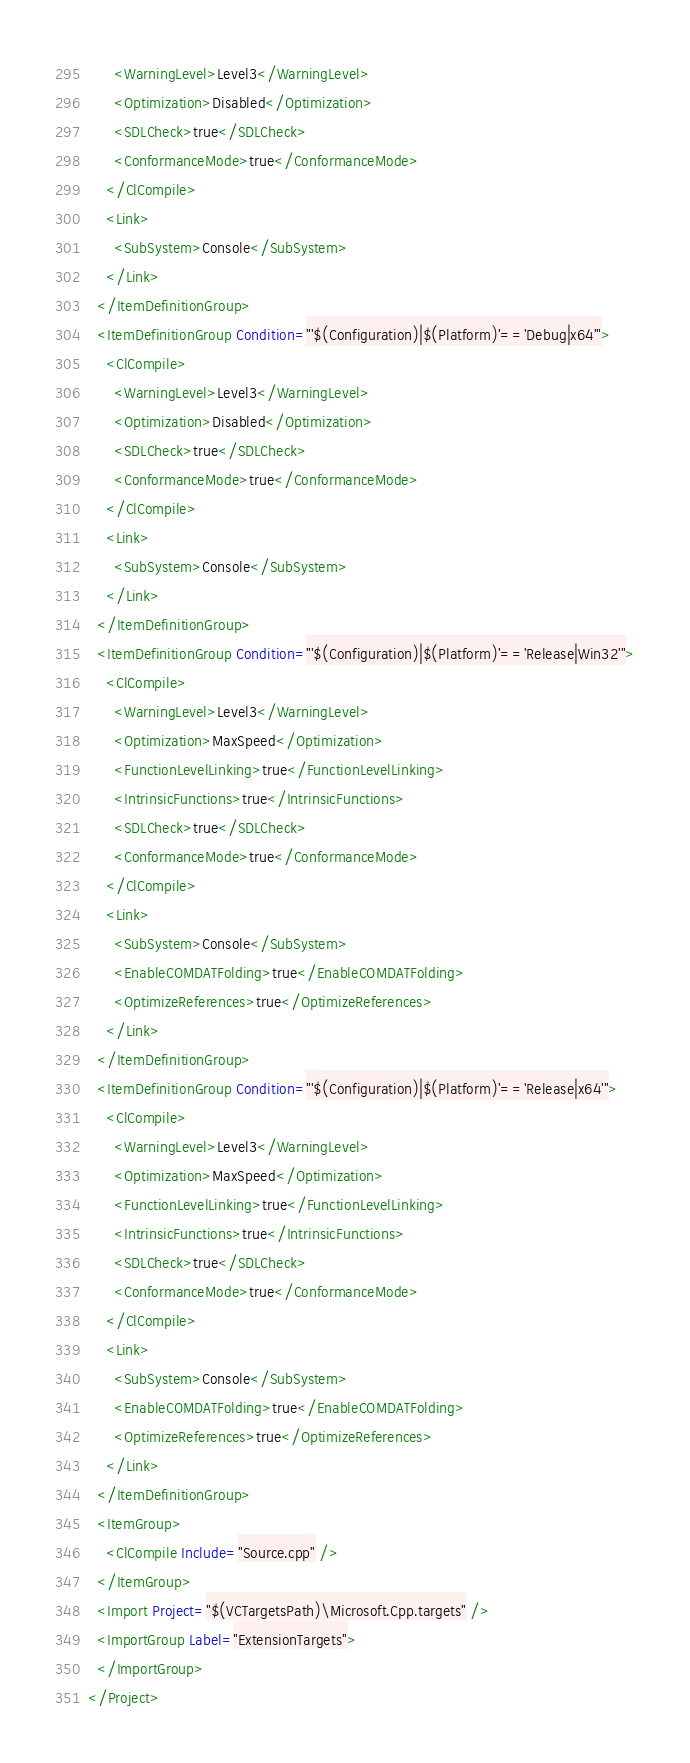<code> <loc_0><loc_0><loc_500><loc_500><_XML_>      <WarningLevel>Level3</WarningLevel>
      <Optimization>Disabled</Optimization>
      <SDLCheck>true</SDLCheck>
      <ConformanceMode>true</ConformanceMode>
    </ClCompile>
    <Link>
      <SubSystem>Console</SubSystem>
    </Link>
  </ItemDefinitionGroup>
  <ItemDefinitionGroup Condition="'$(Configuration)|$(Platform)'=='Debug|x64'">
    <ClCompile>
      <WarningLevel>Level3</WarningLevel>
      <Optimization>Disabled</Optimization>
      <SDLCheck>true</SDLCheck>
      <ConformanceMode>true</ConformanceMode>
    </ClCompile>
    <Link>
      <SubSystem>Console</SubSystem>
    </Link>
  </ItemDefinitionGroup>
  <ItemDefinitionGroup Condition="'$(Configuration)|$(Platform)'=='Release|Win32'">
    <ClCompile>
      <WarningLevel>Level3</WarningLevel>
      <Optimization>MaxSpeed</Optimization>
      <FunctionLevelLinking>true</FunctionLevelLinking>
      <IntrinsicFunctions>true</IntrinsicFunctions>
      <SDLCheck>true</SDLCheck>
      <ConformanceMode>true</ConformanceMode>
    </ClCompile>
    <Link>
      <SubSystem>Console</SubSystem>
      <EnableCOMDATFolding>true</EnableCOMDATFolding>
      <OptimizeReferences>true</OptimizeReferences>
    </Link>
  </ItemDefinitionGroup>
  <ItemDefinitionGroup Condition="'$(Configuration)|$(Platform)'=='Release|x64'">
    <ClCompile>
      <WarningLevel>Level3</WarningLevel>
      <Optimization>MaxSpeed</Optimization>
      <FunctionLevelLinking>true</FunctionLevelLinking>
      <IntrinsicFunctions>true</IntrinsicFunctions>
      <SDLCheck>true</SDLCheck>
      <ConformanceMode>true</ConformanceMode>
    </ClCompile>
    <Link>
      <SubSystem>Console</SubSystem>
      <EnableCOMDATFolding>true</EnableCOMDATFolding>
      <OptimizeReferences>true</OptimizeReferences>
    </Link>
  </ItemDefinitionGroup>
  <ItemGroup>
    <ClCompile Include="Source.cpp" />
  </ItemGroup>
  <Import Project="$(VCTargetsPath)\Microsoft.Cpp.targets" />
  <ImportGroup Label="ExtensionTargets">
  </ImportGroup>
</Project></code> 